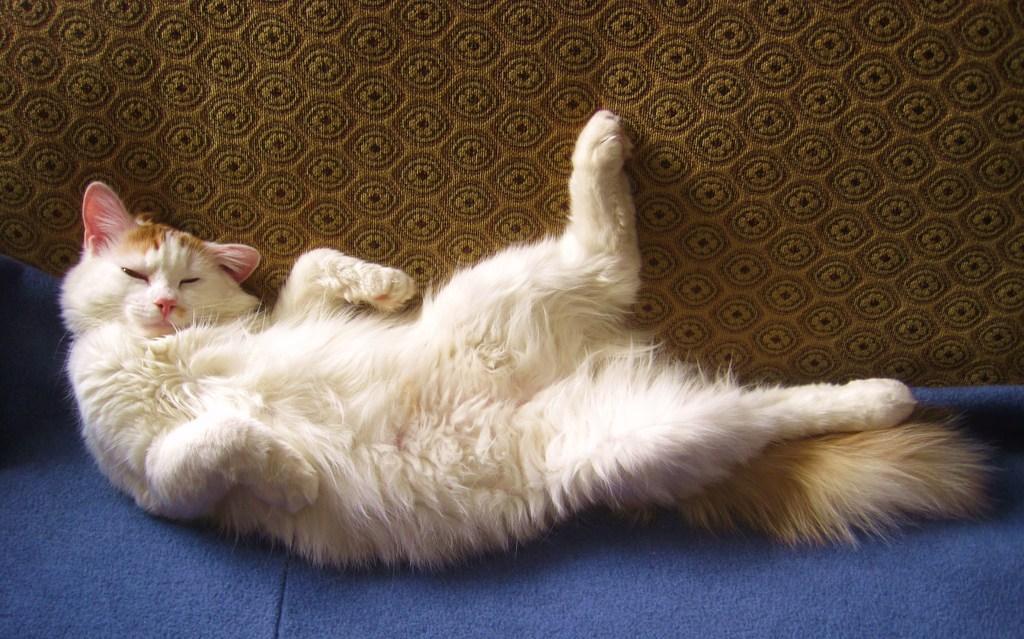Describe this image in one or two sentences. In the center of the image there is a cat on the carpet. 